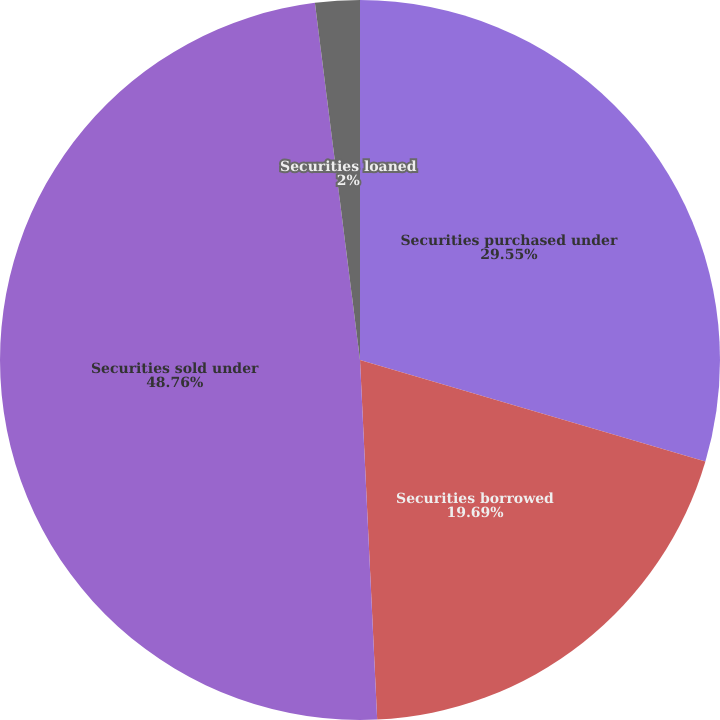<chart> <loc_0><loc_0><loc_500><loc_500><pie_chart><fcel>Securities purchased under<fcel>Securities borrowed<fcel>Securities sold under<fcel>Securities loaned<nl><fcel>29.55%<fcel>19.69%<fcel>48.76%<fcel>2.0%<nl></chart> 